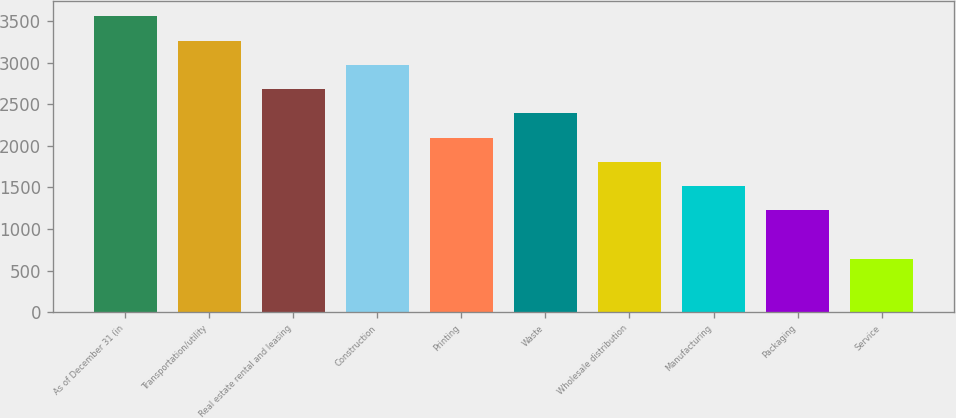Convert chart. <chart><loc_0><loc_0><loc_500><loc_500><bar_chart><fcel>As of December 31 (in<fcel>Transportation/utility<fcel>Real estate rental and leasing<fcel>Construction<fcel>Printing<fcel>Waste<fcel>Wholesale distribution<fcel>Manufacturing<fcel>Packaging<fcel>Service<nl><fcel>3556.72<fcel>3265.01<fcel>2681.59<fcel>2973.3<fcel>2098.17<fcel>2389.88<fcel>1806.46<fcel>1514.75<fcel>1223.04<fcel>639.62<nl></chart> 